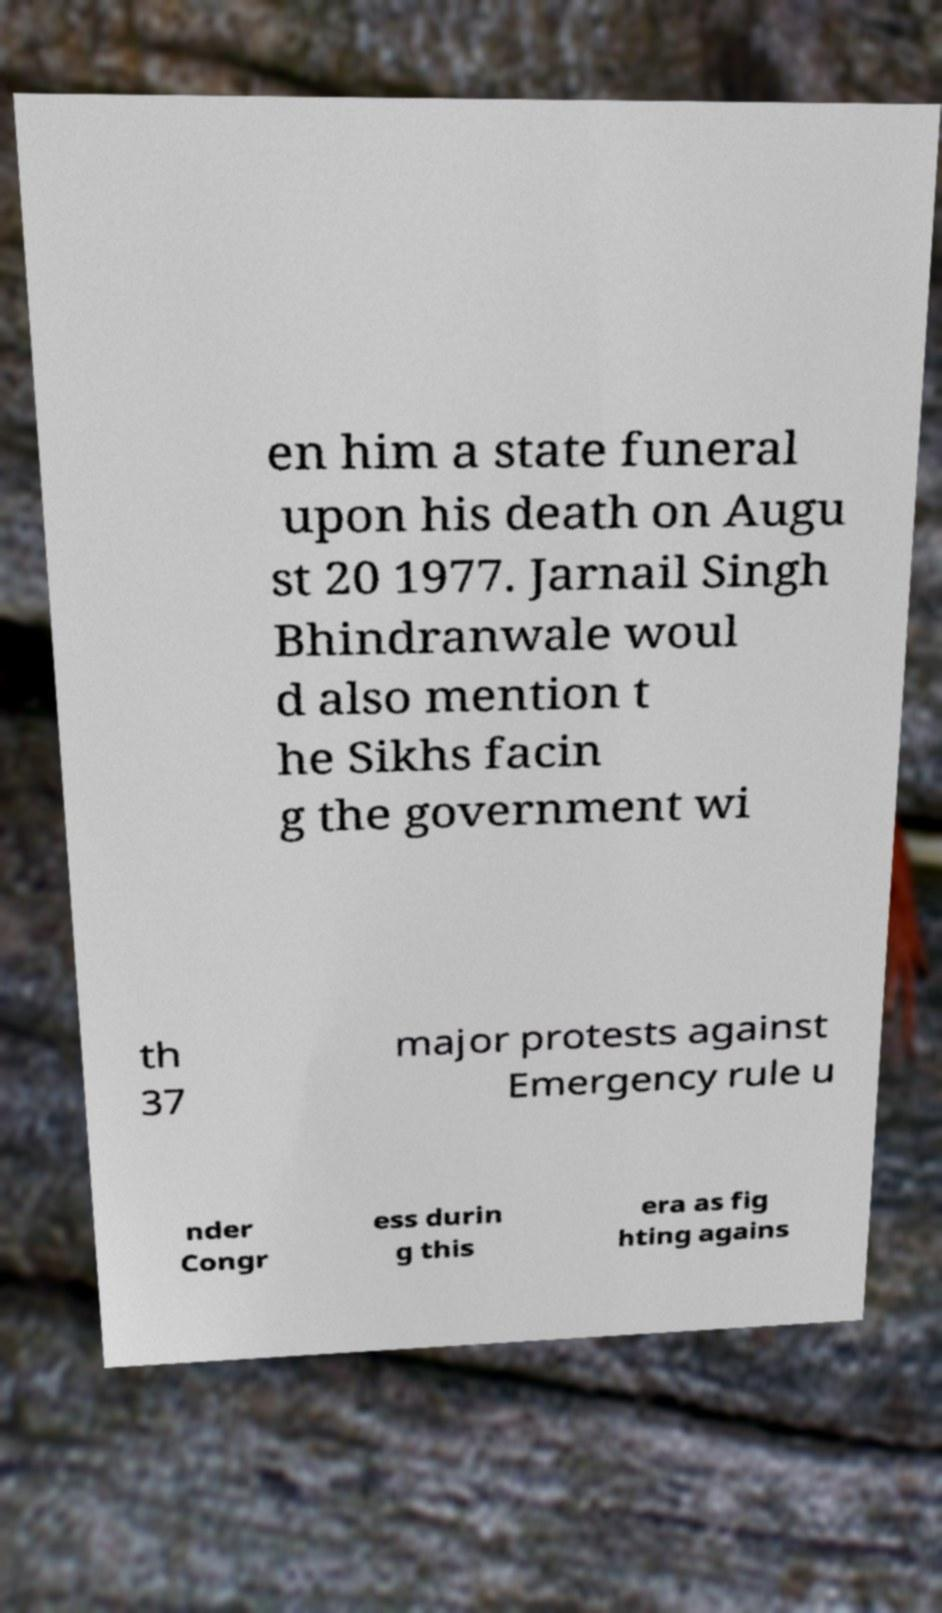There's text embedded in this image that I need extracted. Can you transcribe it verbatim? en him a state funeral upon his death on Augu st 20 1977. Jarnail Singh Bhindranwale woul d also mention t he Sikhs facin g the government wi th 37 major protests against Emergency rule u nder Congr ess durin g this era as fig hting agains 